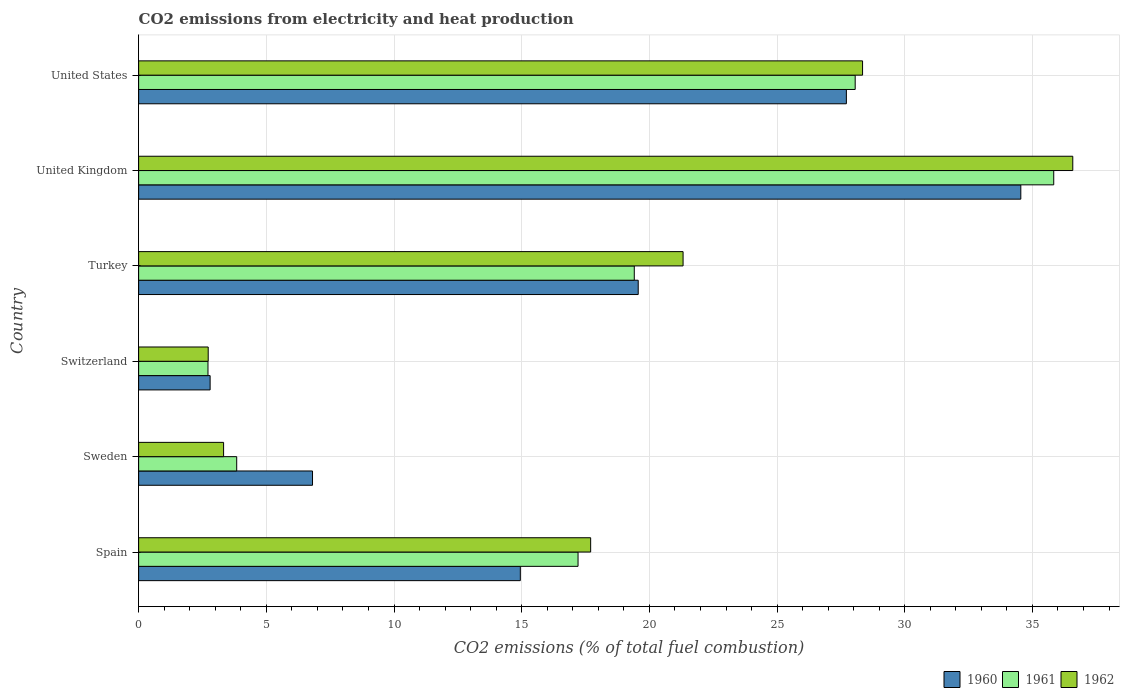How many groups of bars are there?
Your response must be concise. 6. Are the number of bars per tick equal to the number of legend labels?
Make the answer very short. Yes. Are the number of bars on each tick of the Y-axis equal?
Ensure brevity in your answer.  Yes. How many bars are there on the 1st tick from the top?
Ensure brevity in your answer.  3. How many bars are there on the 4th tick from the bottom?
Keep it short and to the point. 3. What is the label of the 4th group of bars from the top?
Your answer should be compact. Switzerland. In how many cases, is the number of bars for a given country not equal to the number of legend labels?
Your answer should be very brief. 0. What is the amount of CO2 emitted in 1961 in Spain?
Give a very brief answer. 17.21. Across all countries, what is the maximum amount of CO2 emitted in 1960?
Offer a terse response. 34.54. Across all countries, what is the minimum amount of CO2 emitted in 1960?
Provide a short and direct response. 2.8. In which country was the amount of CO2 emitted in 1960 minimum?
Your response must be concise. Switzerland. What is the total amount of CO2 emitted in 1960 in the graph?
Ensure brevity in your answer.  106.38. What is the difference between the amount of CO2 emitted in 1962 in Spain and that in United Kingdom?
Ensure brevity in your answer.  -18.88. What is the difference between the amount of CO2 emitted in 1961 in Turkey and the amount of CO2 emitted in 1962 in Switzerland?
Your answer should be compact. 16.68. What is the average amount of CO2 emitted in 1960 per country?
Your response must be concise. 17.73. What is the difference between the amount of CO2 emitted in 1962 and amount of CO2 emitted in 1961 in United Kingdom?
Your response must be concise. 0.75. What is the ratio of the amount of CO2 emitted in 1962 in Sweden to that in United States?
Make the answer very short. 0.12. What is the difference between the highest and the second highest amount of CO2 emitted in 1962?
Provide a short and direct response. 8.23. What is the difference between the highest and the lowest amount of CO2 emitted in 1960?
Offer a very short reply. 31.74. What does the 3rd bar from the top in United States represents?
Provide a short and direct response. 1960. Is it the case that in every country, the sum of the amount of CO2 emitted in 1962 and amount of CO2 emitted in 1961 is greater than the amount of CO2 emitted in 1960?
Provide a succinct answer. Yes. How many bars are there?
Your response must be concise. 18. How many countries are there in the graph?
Ensure brevity in your answer.  6. Does the graph contain any zero values?
Make the answer very short. No. Does the graph contain grids?
Your answer should be compact. Yes. Where does the legend appear in the graph?
Offer a very short reply. Bottom right. What is the title of the graph?
Give a very brief answer. CO2 emissions from electricity and heat production. Does "1976" appear as one of the legend labels in the graph?
Your answer should be compact. No. What is the label or title of the X-axis?
Provide a succinct answer. CO2 emissions (% of total fuel combustion). What is the CO2 emissions (% of total fuel combustion) in 1960 in Spain?
Provide a succinct answer. 14.95. What is the CO2 emissions (% of total fuel combustion) in 1961 in Spain?
Give a very brief answer. 17.21. What is the CO2 emissions (% of total fuel combustion) of 1962 in Spain?
Provide a short and direct response. 17.7. What is the CO2 emissions (% of total fuel combustion) of 1960 in Sweden?
Keep it short and to the point. 6.81. What is the CO2 emissions (% of total fuel combustion) in 1961 in Sweden?
Offer a terse response. 3.84. What is the CO2 emissions (% of total fuel combustion) of 1962 in Sweden?
Offer a very short reply. 3.33. What is the CO2 emissions (% of total fuel combustion) in 1960 in Switzerland?
Offer a very short reply. 2.8. What is the CO2 emissions (% of total fuel combustion) in 1961 in Switzerland?
Ensure brevity in your answer.  2.72. What is the CO2 emissions (% of total fuel combustion) in 1962 in Switzerland?
Offer a terse response. 2.72. What is the CO2 emissions (% of total fuel combustion) of 1960 in Turkey?
Offer a very short reply. 19.56. What is the CO2 emissions (% of total fuel combustion) of 1961 in Turkey?
Offer a very short reply. 19.41. What is the CO2 emissions (% of total fuel combustion) of 1962 in Turkey?
Provide a short and direct response. 21.32. What is the CO2 emissions (% of total fuel combustion) of 1960 in United Kingdom?
Make the answer very short. 34.54. What is the CO2 emissions (% of total fuel combustion) of 1961 in United Kingdom?
Keep it short and to the point. 35.83. What is the CO2 emissions (% of total fuel combustion) of 1962 in United Kingdom?
Provide a succinct answer. 36.58. What is the CO2 emissions (% of total fuel combustion) in 1960 in United States?
Offer a terse response. 27.71. What is the CO2 emissions (% of total fuel combustion) in 1961 in United States?
Your response must be concise. 28.06. What is the CO2 emissions (% of total fuel combustion) in 1962 in United States?
Offer a very short reply. 28.35. Across all countries, what is the maximum CO2 emissions (% of total fuel combustion) in 1960?
Your answer should be very brief. 34.54. Across all countries, what is the maximum CO2 emissions (% of total fuel combustion) of 1961?
Ensure brevity in your answer.  35.83. Across all countries, what is the maximum CO2 emissions (% of total fuel combustion) of 1962?
Your response must be concise. 36.58. Across all countries, what is the minimum CO2 emissions (% of total fuel combustion) in 1960?
Ensure brevity in your answer.  2.8. Across all countries, what is the minimum CO2 emissions (% of total fuel combustion) in 1961?
Your answer should be compact. 2.72. Across all countries, what is the minimum CO2 emissions (% of total fuel combustion) of 1962?
Offer a terse response. 2.72. What is the total CO2 emissions (% of total fuel combustion) in 1960 in the graph?
Offer a terse response. 106.38. What is the total CO2 emissions (% of total fuel combustion) of 1961 in the graph?
Provide a succinct answer. 107.06. What is the total CO2 emissions (% of total fuel combustion) of 1962 in the graph?
Your answer should be compact. 110. What is the difference between the CO2 emissions (% of total fuel combustion) in 1960 in Spain and that in Sweden?
Provide a short and direct response. 8.14. What is the difference between the CO2 emissions (% of total fuel combustion) of 1961 in Spain and that in Sweden?
Keep it short and to the point. 13.37. What is the difference between the CO2 emissions (% of total fuel combustion) in 1962 in Spain and that in Sweden?
Your answer should be compact. 14.37. What is the difference between the CO2 emissions (% of total fuel combustion) in 1960 in Spain and that in Switzerland?
Give a very brief answer. 12.15. What is the difference between the CO2 emissions (% of total fuel combustion) in 1961 in Spain and that in Switzerland?
Your answer should be very brief. 14.49. What is the difference between the CO2 emissions (% of total fuel combustion) in 1962 in Spain and that in Switzerland?
Offer a terse response. 14.98. What is the difference between the CO2 emissions (% of total fuel combustion) of 1960 in Spain and that in Turkey?
Offer a very short reply. -4.62. What is the difference between the CO2 emissions (% of total fuel combustion) in 1961 in Spain and that in Turkey?
Offer a very short reply. -2.2. What is the difference between the CO2 emissions (% of total fuel combustion) in 1962 in Spain and that in Turkey?
Your answer should be very brief. -3.62. What is the difference between the CO2 emissions (% of total fuel combustion) of 1960 in Spain and that in United Kingdom?
Your answer should be very brief. -19.6. What is the difference between the CO2 emissions (% of total fuel combustion) of 1961 in Spain and that in United Kingdom?
Provide a short and direct response. -18.63. What is the difference between the CO2 emissions (% of total fuel combustion) in 1962 in Spain and that in United Kingdom?
Offer a terse response. -18.88. What is the difference between the CO2 emissions (% of total fuel combustion) of 1960 in Spain and that in United States?
Give a very brief answer. -12.77. What is the difference between the CO2 emissions (% of total fuel combustion) in 1961 in Spain and that in United States?
Provide a succinct answer. -10.85. What is the difference between the CO2 emissions (% of total fuel combustion) in 1962 in Spain and that in United States?
Your answer should be compact. -10.65. What is the difference between the CO2 emissions (% of total fuel combustion) of 1960 in Sweden and that in Switzerland?
Keep it short and to the point. 4.01. What is the difference between the CO2 emissions (% of total fuel combustion) in 1961 in Sweden and that in Switzerland?
Provide a succinct answer. 1.12. What is the difference between the CO2 emissions (% of total fuel combustion) of 1962 in Sweden and that in Switzerland?
Keep it short and to the point. 0.6. What is the difference between the CO2 emissions (% of total fuel combustion) in 1960 in Sweden and that in Turkey?
Keep it short and to the point. -12.75. What is the difference between the CO2 emissions (% of total fuel combustion) in 1961 in Sweden and that in Turkey?
Provide a succinct answer. -15.57. What is the difference between the CO2 emissions (% of total fuel combustion) in 1962 in Sweden and that in Turkey?
Keep it short and to the point. -17.99. What is the difference between the CO2 emissions (% of total fuel combustion) in 1960 in Sweden and that in United Kingdom?
Your answer should be very brief. -27.74. What is the difference between the CO2 emissions (% of total fuel combustion) in 1961 in Sweden and that in United Kingdom?
Give a very brief answer. -31.99. What is the difference between the CO2 emissions (% of total fuel combustion) of 1962 in Sweden and that in United Kingdom?
Ensure brevity in your answer.  -33.25. What is the difference between the CO2 emissions (% of total fuel combustion) of 1960 in Sweden and that in United States?
Provide a short and direct response. -20.9. What is the difference between the CO2 emissions (% of total fuel combustion) of 1961 in Sweden and that in United States?
Your answer should be compact. -24.22. What is the difference between the CO2 emissions (% of total fuel combustion) of 1962 in Sweden and that in United States?
Your response must be concise. -25.02. What is the difference between the CO2 emissions (% of total fuel combustion) in 1960 in Switzerland and that in Turkey?
Provide a short and direct response. -16.76. What is the difference between the CO2 emissions (% of total fuel combustion) in 1961 in Switzerland and that in Turkey?
Offer a terse response. -16.69. What is the difference between the CO2 emissions (% of total fuel combustion) of 1962 in Switzerland and that in Turkey?
Offer a very short reply. -18.59. What is the difference between the CO2 emissions (% of total fuel combustion) in 1960 in Switzerland and that in United Kingdom?
Your response must be concise. -31.74. What is the difference between the CO2 emissions (% of total fuel combustion) of 1961 in Switzerland and that in United Kingdom?
Ensure brevity in your answer.  -33.12. What is the difference between the CO2 emissions (% of total fuel combustion) of 1962 in Switzerland and that in United Kingdom?
Your answer should be very brief. -33.85. What is the difference between the CO2 emissions (% of total fuel combustion) in 1960 in Switzerland and that in United States?
Offer a very short reply. -24.91. What is the difference between the CO2 emissions (% of total fuel combustion) in 1961 in Switzerland and that in United States?
Provide a succinct answer. -25.34. What is the difference between the CO2 emissions (% of total fuel combustion) in 1962 in Switzerland and that in United States?
Provide a short and direct response. -25.62. What is the difference between the CO2 emissions (% of total fuel combustion) in 1960 in Turkey and that in United Kingdom?
Make the answer very short. -14.98. What is the difference between the CO2 emissions (% of total fuel combustion) in 1961 in Turkey and that in United Kingdom?
Ensure brevity in your answer.  -16.42. What is the difference between the CO2 emissions (% of total fuel combustion) in 1962 in Turkey and that in United Kingdom?
Your answer should be compact. -15.26. What is the difference between the CO2 emissions (% of total fuel combustion) in 1960 in Turkey and that in United States?
Your answer should be compact. -8.15. What is the difference between the CO2 emissions (% of total fuel combustion) in 1961 in Turkey and that in United States?
Offer a very short reply. -8.65. What is the difference between the CO2 emissions (% of total fuel combustion) of 1962 in Turkey and that in United States?
Make the answer very short. -7.03. What is the difference between the CO2 emissions (% of total fuel combustion) of 1960 in United Kingdom and that in United States?
Offer a terse response. 6.83. What is the difference between the CO2 emissions (% of total fuel combustion) in 1961 in United Kingdom and that in United States?
Provide a short and direct response. 7.77. What is the difference between the CO2 emissions (% of total fuel combustion) in 1962 in United Kingdom and that in United States?
Make the answer very short. 8.23. What is the difference between the CO2 emissions (% of total fuel combustion) of 1960 in Spain and the CO2 emissions (% of total fuel combustion) of 1961 in Sweden?
Your answer should be very brief. 11.11. What is the difference between the CO2 emissions (% of total fuel combustion) in 1960 in Spain and the CO2 emissions (% of total fuel combustion) in 1962 in Sweden?
Ensure brevity in your answer.  11.62. What is the difference between the CO2 emissions (% of total fuel combustion) in 1961 in Spain and the CO2 emissions (% of total fuel combustion) in 1962 in Sweden?
Give a very brief answer. 13.88. What is the difference between the CO2 emissions (% of total fuel combustion) of 1960 in Spain and the CO2 emissions (% of total fuel combustion) of 1961 in Switzerland?
Your answer should be compact. 12.23. What is the difference between the CO2 emissions (% of total fuel combustion) of 1960 in Spain and the CO2 emissions (% of total fuel combustion) of 1962 in Switzerland?
Give a very brief answer. 12.22. What is the difference between the CO2 emissions (% of total fuel combustion) of 1961 in Spain and the CO2 emissions (% of total fuel combustion) of 1962 in Switzerland?
Provide a short and direct response. 14.48. What is the difference between the CO2 emissions (% of total fuel combustion) of 1960 in Spain and the CO2 emissions (% of total fuel combustion) of 1961 in Turkey?
Give a very brief answer. -4.46. What is the difference between the CO2 emissions (% of total fuel combustion) of 1960 in Spain and the CO2 emissions (% of total fuel combustion) of 1962 in Turkey?
Keep it short and to the point. -6.37. What is the difference between the CO2 emissions (% of total fuel combustion) of 1961 in Spain and the CO2 emissions (% of total fuel combustion) of 1962 in Turkey?
Provide a short and direct response. -4.11. What is the difference between the CO2 emissions (% of total fuel combustion) of 1960 in Spain and the CO2 emissions (% of total fuel combustion) of 1961 in United Kingdom?
Offer a very short reply. -20.89. What is the difference between the CO2 emissions (% of total fuel combustion) of 1960 in Spain and the CO2 emissions (% of total fuel combustion) of 1962 in United Kingdom?
Offer a very short reply. -21.63. What is the difference between the CO2 emissions (% of total fuel combustion) of 1961 in Spain and the CO2 emissions (% of total fuel combustion) of 1962 in United Kingdom?
Your answer should be very brief. -19.37. What is the difference between the CO2 emissions (% of total fuel combustion) in 1960 in Spain and the CO2 emissions (% of total fuel combustion) in 1961 in United States?
Your answer should be compact. -13.11. What is the difference between the CO2 emissions (% of total fuel combustion) of 1960 in Spain and the CO2 emissions (% of total fuel combustion) of 1962 in United States?
Make the answer very short. -13.4. What is the difference between the CO2 emissions (% of total fuel combustion) of 1961 in Spain and the CO2 emissions (% of total fuel combustion) of 1962 in United States?
Ensure brevity in your answer.  -11.14. What is the difference between the CO2 emissions (% of total fuel combustion) of 1960 in Sweden and the CO2 emissions (% of total fuel combustion) of 1961 in Switzerland?
Offer a very short reply. 4.09. What is the difference between the CO2 emissions (% of total fuel combustion) of 1960 in Sweden and the CO2 emissions (% of total fuel combustion) of 1962 in Switzerland?
Ensure brevity in your answer.  4.08. What is the difference between the CO2 emissions (% of total fuel combustion) in 1961 in Sweden and the CO2 emissions (% of total fuel combustion) in 1962 in Switzerland?
Ensure brevity in your answer.  1.12. What is the difference between the CO2 emissions (% of total fuel combustion) in 1960 in Sweden and the CO2 emissions (% of total fuel combustion) in 1961 in Turkey?
Make the answer very short. -12.6. What is the difference between the CO2 emissions (% of total fuel combustion) of 1960 in Sweden and the CO2 emissions (% of total fuel combustion) of 1962 in Turkey?
Your answer should be very brief. -14.51. What is the difference between the CO2 emissions (% of total fuel combustion) of 1961 in Sweden and the CO2 emissions (% of total fuel combustion) of 1962 in Turkey?
Provide a short and direct response. -17.48. What is the difference between the CO2 emissions (% of total fuel combustion) of 1960 in Sweden and the CO2 emissions (% of total fuel combustion) of 1961 in United Kingdom?
Your answer should be very brief. -29.02. What is the difference between the CO2 emissions (% of total fuel combustion) in 1960 in Sweden and the CO2 emissions (% of total fuel combustion) in 1962 in United Kingdom?
Make the answer very short. -29.77. What is the difference between the CO2 emissions (% of total fuel combustion) in 1961 in Sweden and the CO2 emissions (% of total fuel combustion) in 1962 in United Kingdom?
Offer a very short reply. -32.74. What is the difference between the CO2 emissions (% of total fuel combustion) of 1960 in Sweden and the CO2 emissions (% of total fuel combustion) of 1961 in United States?
Give a very brief answer. -21.25. What is the difference between the CO2 emissions (% of total fuel combustion) in 1960 in Sweden and the CO2 emissions (% of total fuel combustion) in 1962 in United States?
Your answer should be compact. -21.54. What is the difference between the CO2 emissions (% of total fuel combustion) of 1961 in Sweden and the CO2 emissions (% of total fuel combustion) of 1962 in United States?
Your response must be concise. -24.51. What is the difference between the CO2 emissions (% of total fuel combustion) in 1960 in Switzerland and the CO2 emissions (% of total fuel combustion) in 1961 in Turkey?
Keep it short and to the point. -16.61. What is the difference between the CO2 emissions (% of total fuel combustion) of 1960 in Switzerland and the CO2 emissions (% of total fuel combustion) of 1962 in Turkey?
Offer a terse response. -18.52. What is the difference between the CO2 emissions (% of total fuel combustion) of 1961 in Switzerland and the CO2 emissions (% of total fuel combustion) of 1962 in Turkey?
Your answer should be very brief. -18.6. What is the difference between the CO2 emissions (% of total fuel combustion) of 1960 in Switzerland and the CO2 emissions (% of total fuel combustion) of 1961 in United Kingdom?
Make the answer very short. -33.03. What is the difference between the CO2 emissions (% of total fuel combustion) in 1960 in Switzerland and the CO2 emissions (% of total fuel combustion) in 1962 in United Kingdom?
Make the answer very short. -33.78. What is the difference between the CO2 emissions (% of total fuel combustion) in 1961 in Switzerland and the CO2 emissions (% of total fuel combustion) in 1962 in United Kingdom?
Your answer should be compact. -33.86. What is the difference between the CO2 emissions (% of total fuel combustion) in 1960 in Switzerland and the CO2 emissions (% of total fuel combustion) in 1961 in United States?
Keep it short and to the point. -25.26. What is the difference between the CO2 emissions (% of total fuel combustion) in 1960 in Switzerland and the CO2 emissions (% of total fuel combustion) in 1962 in United States?
Provide a short and direct response. -25.55. What is the difference between the CO2 emissions (% of total fuel combustion) in 1961 in Switzerland and the CO2 emissions (% of total fuel combustion) in 1962 in United States?
Provide a succinct answer. -25.63. What is the difference between the CO2 emissions (% of total fuel combustion) of 1960 in Turkey and the CO2 emissions (% of total fuel combustion) of 1961 in United Kingdom?
Make the answer very short. -16.27. What is the difference between the CO2 emissions (% of total fuel combustion) of 1960 in Turkey and the CO2 emissions (% of total fuel combustion) of 1962 in United Kingdom?
Your response must be concise. -17.02. What is the difference between the CO2 emissions (% of total fuel combustion) in 1961 in Turkey and the CO2 emissions (% of total fuel combustion) in 1962 in United Kingdom?
Your answer should be compact. -17.17. What is the difference between the CO2 emissions (% of total fuel combustion) of 1960 in Turkey and the CO2 emissions (% of total fuel combustion) of 1961 in United States?
Offer a very short reply. -8.5. What is the difference between the CO2 emissions (% of total fuel combustion) of 1960 in Turkey and the CO2 emissions (% of total fuel combustion) of 1962 in United States?
Ensure brevity in your answer.  -8.79. What is the difference between the CO2 emissions (% of total fuel combustion) of 1961 in Turkey and the CO2 emissions (% of total fuel combustion) of 1962 in United States?
Keep it short and to the point. -8.94. What is the difference between the CO2 emissions (% of total fuel combustion) in 1960 in United Kingdom and the CO2 emissions (% of total fuel combustion) in 1961 in United States?
Your answer should be very brief. 6.49. What is the difference between the CO2 emissions (% of total fuel combustion) of 1960 in United Kingdom and the CO2 emissions (% of total fuel combustion) of 1962 in United States?
Your answer should be compact. 6.2. What is the difference between the CO2 emissions (% of total fuel combustion) in 1961 in United Kingdom and the CO2 emissions (% of total fuel combustion) in 1962 in United States?
Keep it short and to the point. 7.49. What is the average CO2 emissions (% of total fuel combustion) of 1960 per country?
Make the answer very short. 17.73. What is the average CO2 emissions (% of total fuel combustion) of 1961 per country?
Keep it short and to the point. 17.84. What is the average CO2 emissions (% of total fuel combustion) of 1962 per country?
Offer a very short reply. 18.33. What is the difference between the CO2 emissions (% of total fuel combustion) in 1960 and CO2 emissions (% of total fuel combustion) in 1961 in Spain?
Provide a succinct answer. -2.26. What is the difference between the CO2 emissions (% of total fuel combustion) of 1960 and CO2 emissions (% of total fuel combustion) of 1962 in Spain?
Offer a very short reply. -2.75. What is the difference between the CO2 emissions (% of total fuel combustion) of 1961 and CO2 emissions (% of total fuel combustion) of 1962 in Spain?
Ensure brevity in your answer.  -0.49. What is the difference between the CO2 emissions (% of total fuel combustion) in 1960 and CO2 emissions (% of total fuel combustion) in 1961 in Sweden?
Provide a short and direct response. 2.97. What is the difference between the CO2 emissions (% of total fuel combustion) of 1960 and CO2 emissions (% of total fuel combustion) of 1962 in Sweden?
Your answer should be very brief. 3.48. What is the difference between the CO2 emissions (% of total fuel combustion) of 1961 and CO2 emissions (% of total fuel combustion) of 1962 in Sweden?
Make the answer very short. 0.51. What is the difference between the CO2 emissions (% of total fuel combustion) in 1960 and CO2 emissions (% of total fuel combustion) in 1961 in Switzerland?
Offer a terse response. 0.08. What is the difference between the CO2 emissions (% of total fuel combustion) of 1960 and CO2 emissions (% of total fuel combustion) of 1962 in Switzerland?
Offer a very short reply. 0.07. What is the difference between the CO2 emissions (% of total fuel combustion) of 1961 and CO2 emissions (% of total fuel combustion) of 1962 in Switzerland?
Offer a very short reply. -0.01. What is the difference between the CO2 emissions (% of total fuel combustion) of 1960 and CO2 emissions (% of total fuel combustion) of 1961 in Turkey?
Offer a very short reply. 0.15. What is the difference between the CO2 emissions (% of total fuel combustion) of 1960 and CO2 emissions (% of total fuel combustion) of 1962 in Turkey?
Make the answer very short. -1.76. What is the difference between the CO2 emissions (% of total fuel combustion) of 1961 and CO2 emissions (% of total fuel combustion) of 1962 in Turkey?
Make the answer very short. -1.91. What is the difference between the CO2 emissions (% of total fuel combustion) in 1960 and CO2 emissions (% of total fuel combustion) in 1961 in United Kingdom?
Make the answer very short. -1.29. What is the difference between the CO2 emissions (% of total fuel combustion) in 1960 and CO2 emissions (% of total fuel combustion) in 1962 in United Kingdom?
Offer a terse response. -2.03. What is the difference between the CO2 emissions (% of total fuel combustion) of 1961 and CO2 emissions (% of total fuel combustion) of 1962 in United Kingdom?
Your answer should be very brief. -0.75. What is the difference between the CO2 emissions (% of total fuel combustion) of 1960 and CO2 emissions (% of total fuel combustion) of 1961 in United States?
Keep it short and to the point. -0.35. What is the difference between the CO2 emissions (% of total fuel combustion) in 1960 and CO2 emissions (% of total fuel combustion) in 1962 in United States?
Offer a very short reply. -0.63. What is the difference between the CO2 emissions (% of total fuel combustion) in 1961 and CO2 emissions (% of total fuel combustion) in 1962 in United States?
Your response must be concise. -0.29. What is the ratio of the CO2 emissions (% of total fuel combustion) of 1960 in Spain to that in Sweden?
Your response must be concise. 2.2. What is the ratio of the CO2 emissions (% of total fuel combustion) in 1961 in Spain to that in Sweden?
Make the answer very short. 4.48. What is the ratio of the CO2 emissions (% of total fuel combustion) in 1962 in Spain to that in Sweden?
Offer a terse response. 5.32. What is the ratio of the CO2 emissions (% of total fuel combustion) of 1960 in Spain to that in Switzerland?
Give a very brief answer. 5.34. What is the ratio of the CO2 emissions (% of total fuel combustion) of 1961 in Spain to that in Switzerland?
Your answer should be very brief. 6.34. What is the ratio of the CO2 emissions (% of total fuel combustion) of 1962 in Spain to that in Switzerland?
Your response must be concise. 6.5. What is the ratio of the CO2 emissions (% of total fuel combustion) in 1960 in Spain to that in Turkey?
Your answer should be very brief. 0.76. What is the ratio of the CO2 emissions (% of total fuel combustion) of 1961 in Spain to that in Turkey?
Your response must be concise. 0.89. What is the ratio of the CO2 emissions (% of total fuel combustion) of 1962 in Spain to that in Turkey?
Make the answer very short. 0.83. What is the ratio of the CO2 emissions (% of total fuel combustion) in 1960 in Spain to that in United Kingdom?
Your answer should be compact. 0.43. What is the ratio of the CO2 emissions (% of total fuel combustion) in 1961 in Spain to that in United Kingdom?
Your answer should be compact. 0.48. What is the ratio of the CO2 emissions (% of total fuel combustion) of 1962 in Spain to that in United Kingdom?
Your answer should be very brief. 0.48. What is the ratio of the CO2 emissions (% of total fuel combustion) of 1960 in Spain to that in United States?
Provide a short and direct response. 0.54. What is the ratio of the CO2 emissions (% of total fuel combustion) in 1961 in Spain to that in United States?
Ensure brevity in your answer.  0.61. What is the ratio of the CO2 emissions (% of total fuel combustion) of 1962 in Spain to that in United States?
Offer a very short reply. 0.62. What is the ratio of the CO2 emissions (% of total fuel combustion) of 1960 in Sweden to that in Switzerland?
Provide a short and direct response. 2.43. What is the ratio of the CO2 emissions (% of total fuel combustion) in 1961 in Sweden to that in Switzerland?
Keep it short and to the point. 1.41. What is the ratio of the CO2 emissions (% of total fuel combustion) of 1962 in Sweden to that in Switzerland?
Offer a terse response. 1.22. What is the ratio of the CO2 emissions (% of total fuel combustion) of 1960 in Sweden to that in Turkey?
Provide a short and direct response. 0.35. What is the ratio of the CO2 emissions (% of total fuel combustion) of 1961 in Sweden to that in Turkey?
Offer a very short reply. 0.2. What is the ratio of the CO2 emissions (% of total fuel combustion) in 1962 in Sweden to that in Turkey?
Make the answer very short. 0.16. What is the ratio of the CO2 emissions (% of total fuel combustion) of 1960 in Sweden to that in United Kingdom?
Ensure brevity in your answer.  0.2. What is the ratio of the CO2 emissions (% of total fuel combustion) of 1961 in Sweden to that in United Kingdom?
Offer a terse response. 0.11. What is the ratio of the CO2 emissions (% of total fuel combustion) in 1962 in Sweden to that in United Kingdom?
Keep it short and to the point. 0.09. What is the ratio of the CO2 emissions (% of total fuel combustion) of 1960 in Sweden to that in United States?
Keep it short and to the point. 0.25. What is the ratio of the CO2 emissions (% of total fuel combustion) of 1961 in Sweden to that in United States?
Keep it short and to the point. 0.14. What is the ratio of the CO2 emissions (% of total fuel combustion) in 1962 in Sweden to that in United States?
Give a very brief answer. 0.12. What is the ratio of the CO2 emissions (% of total fuel combustion) in 1960 in Switzerland to that in Turkey?
Make the answer very short. 0.14. What is the ratio of the CO2 emissions (% of total fuel combustion) of 1961 in Switzerland to that in Turkey?
Keep it short and to the point. 0.14. What is the ratio of the CO2 emissions (% of total fuel combustion) of 1962 in Switzerland to that in Turkey?
Your answer should be very brief. 0.13. What is the ratio of the CO2 emissions (% of total fuel combustion) in 1960 in Switzerland to that in United Kingdom?
Keep it short and to the point. 0.08. What is the ratio of the CO2 emissions (% of total fuel combustion) of 1961 in Switzerland to that in United Kingdom?
Keep it short and to the point. 0.08. What is the ratio of the CO2 emissions (% of total fuel combustion) in 1962 in Switzerland to that in United Kingdom?
Make the answer very short. 0.07. What is the ratio of the CO2 emissions (% of total fuel combustion) of 1960 in Switzerland to that in United States?
Offer a very short reply. 0.1. What is the ratio of the CO2 emissions (% of total fuel combustion) of 1961 in Switzerland to that in United States?
Give a very brief answer. 0.1. What is the ratio of the CO2 emissions (% of total fuel combustion) in 1962 in Switzerland to that in United States?
Offer a very short reply. 0.1. What is the ratio of the CO2 emissions (% of total fuel combustion) in 1960 in Turkey to that in United Kingdom?
Provide a succinct answer. 0.57. What is the ratio of the CO2 emissions (% of total fuel combustion) in 1961 in Turkey to that in United Kingdom?
Offer a terse response. 0.54. What is the ratio of the CO2 emissions (% of total fuel combustion) in 1962 in Turkey to that in United Kingdom?
Give a very brief answer. 0.58. What is the ratio of the CO2 emissions (% of total fuel combustion) of 1960 in Turkey to that in United States?
Give a very brief answer. 0.71. What is the ratio of the CO2 emissions (% of total fuel combustion) in 1961 in Turkey to that in United States?
Keep it short and to the point. 0.69. What is the ratio of the CO2 emissions (% of total fuel combustion) in 1962 in Turkey to that in United States?
Keep it short and to the point. 0.75. What is the ratio of the CO2 emissions (% of total fuel combustion) of 1960 in United Kingdom to that in United States?
Give a very brief answer. 1.25. What is the ratio of the CO2 emissions (% of total fuel combustion) of 1961 in United Kingdom to that in United States?
Your answer should be compact. 1.28. What is the ratio of the CO2 emissions (% of total fuel combustion) in 1962 in United Kingdom to that in United States?
Your response must be concise. 1.29. What is the difference between the highest and the second highest CO2 emissions (% of total fuel combustion) in 1960?
Your answer should be compact. 6.83. What is the difference between the highest and the second highest CO2 emissions (% of total fuel combustion) in 1961?
Keep it short and to the point. 7.77. What is the difference between the highest and the second highest CO2 emissions (% of total fuel combustion) in 1962?
Provide a succinct answer. 8.23. What is the difference between the highest and the lowest CO2 emissions (% of total fuel combustion) in 1960?
Your response must be concise. 31.74. What is the difference between the highest and the lowest CO2 emissions (% of total fuel combustion) of 1961?
Make the answer very short. 33.12. What is the difference between the highest and the lowest CO2 emissions (% of total fuel combustion) in 1962?
Keep it short and to the point. 33.85. 